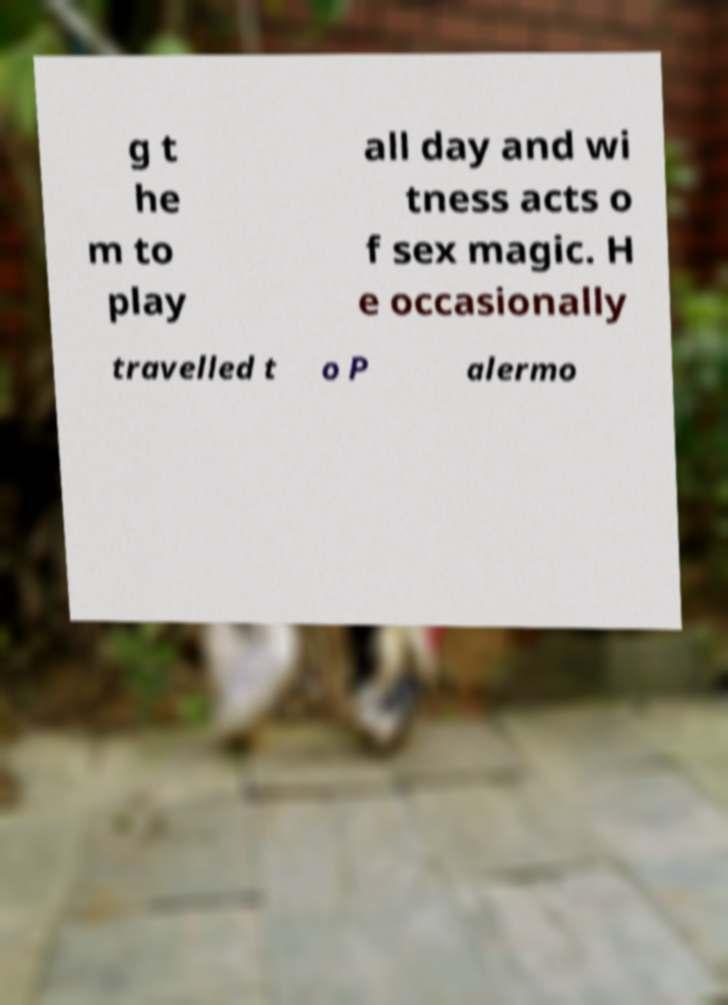Please identify and transcribe the text found in this image. g t he m to play all day and wi tness acts o f sex magic. H e occasionally travelled t o P alermo 